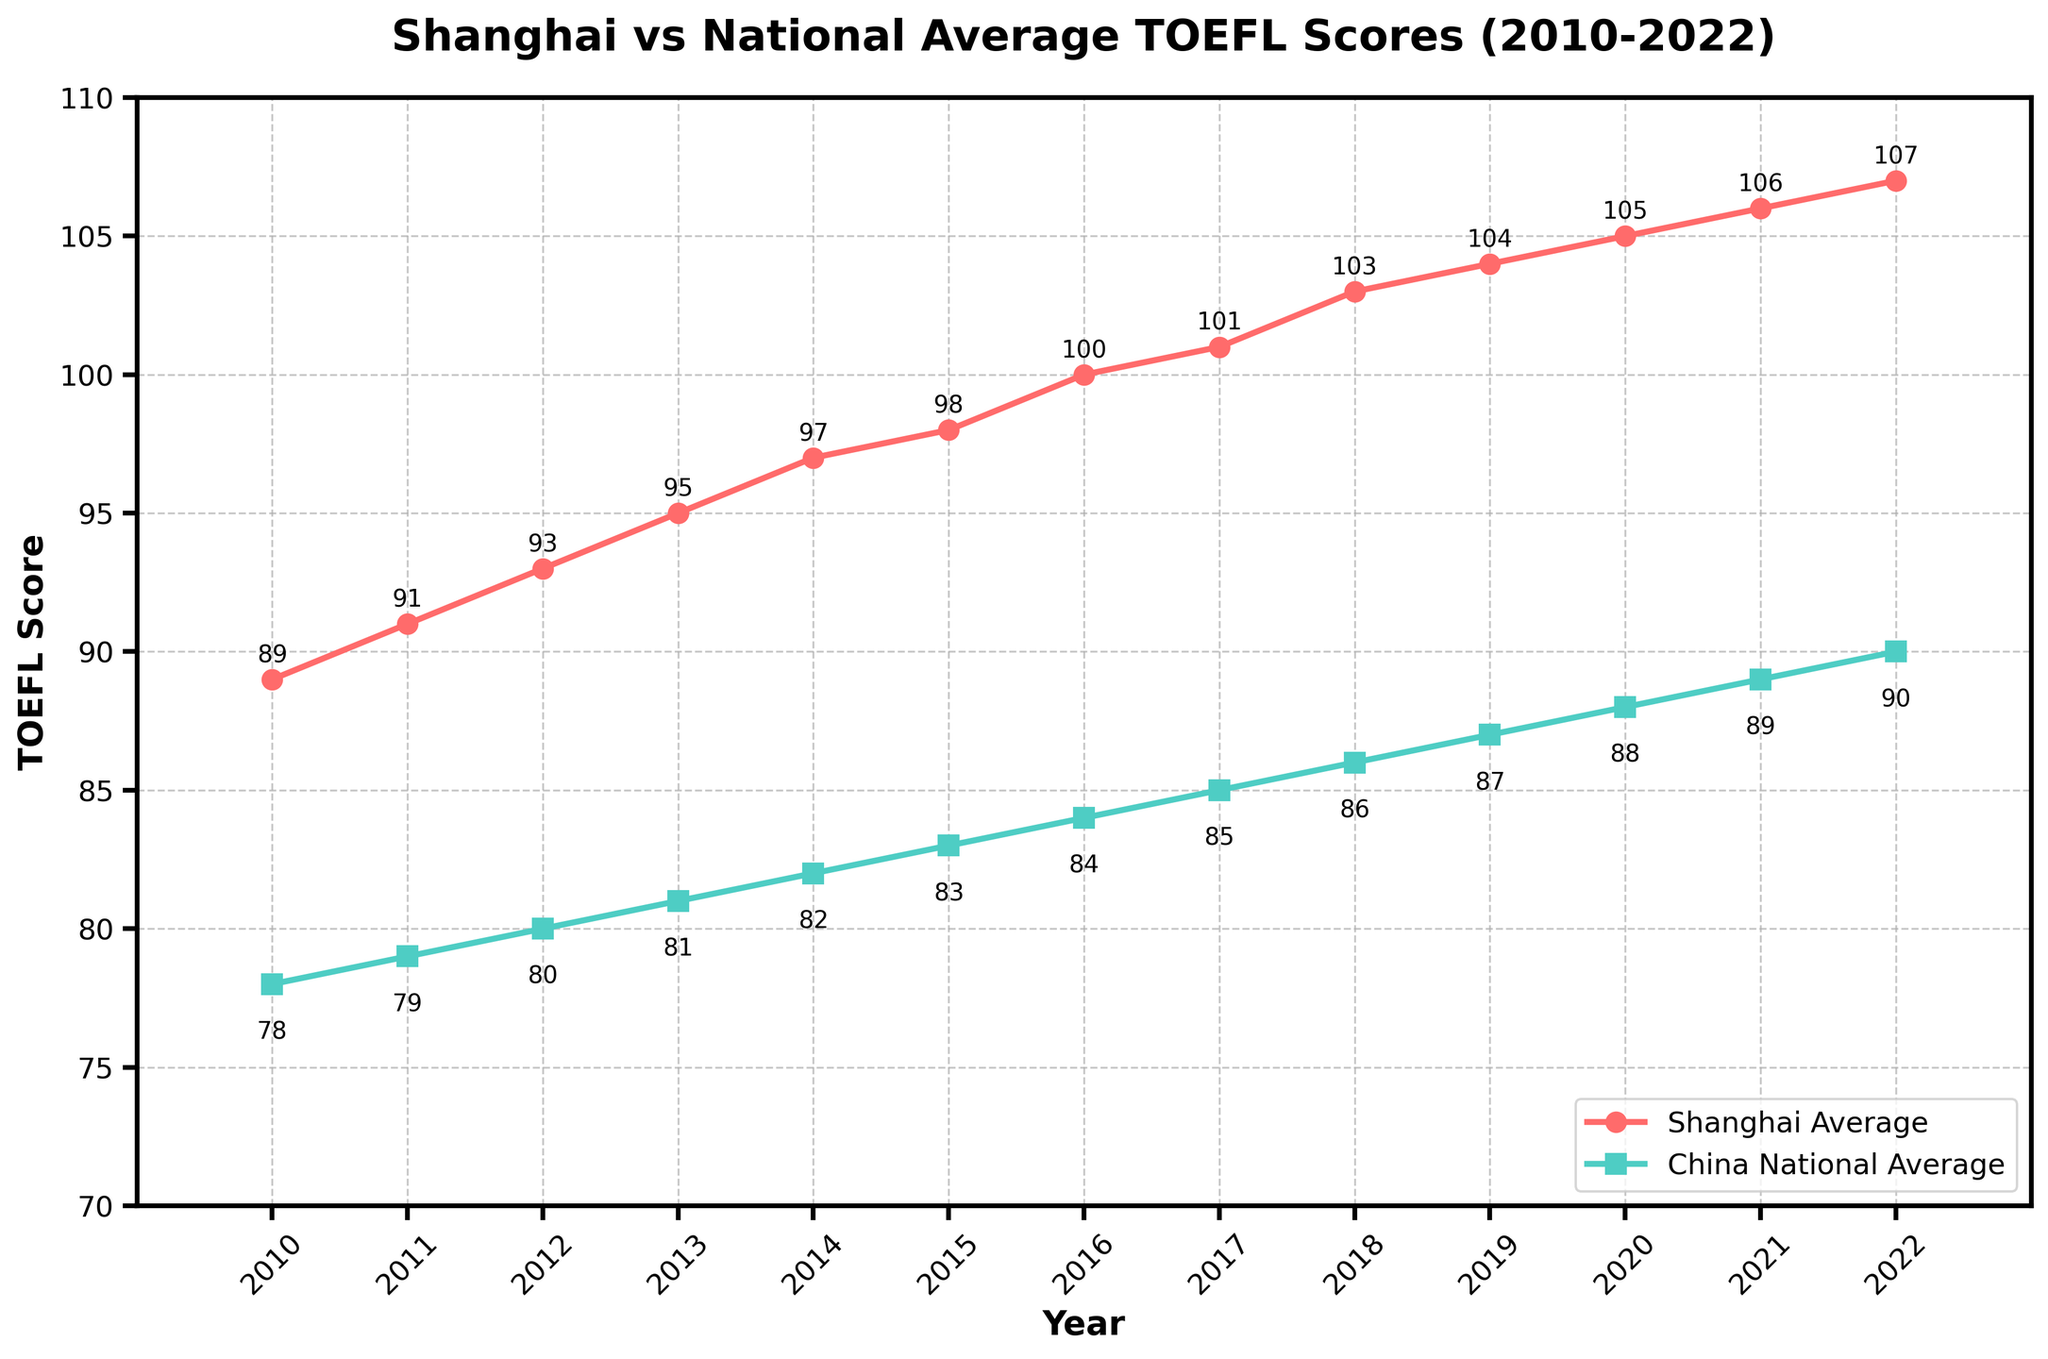What is the TOEFL score difference between Shanghai and the national average in 2015? In 2015, Shanghai's average TOEFL score is 98, and the national average is 83. The difference is 98 - 83 = 15.
Answer: 15 What year did Shanghai first surpass an average TOEFL score of 100? By observing the line chart, Shanghai surpassed an average TOEFL score of 100 in 2016 as the score for that year and subsequent years are 100 or higher.
Answer: 2016 In which year was the gap between Shanghai and the national average the smallest? To determine the smallest gap, we look for the smallest difference between the two lines. In 2010, the difference is 89 - 78 = 11, which is the smallest among all the years.
Answer: 2010 By how much did Shanghai's average TOEFL score increase from 2010 to 2022? Shanghai's average TOEFL score in 2010 was 89, and in 2022 it was 107. The increase is 107 - 89 = 18.
Answer: 18 What is the average national TOEFL score over the 13 years displayed? The national TOEFL scores from 2010 to 2022 are 78, 79, 80, 81, 82, 83, 84, 85, 86, 87, 88, 89, and 90. Summing these scores gives 1092, and the average is 1092 / 13 = 84.
Answer: 84 Which year had the highest TOEFL score in Shanghai? By identifying the peak of the red line, the highest TOEFL score in Shanghai is in 2022, where the score is 107.
Answer: 2022 What is the trend of Shanghai's average TOEFL score from 2010 to 2022? Shanghai's average TOEFL score consistently increases each year from 89 in 2010 to 107 in 2022, indicating a positive upward trend.
Answer: Increasing How much higher was Shanghai’s average score than the national average in 2022? In 2022, Shanghai’s average TOEFL score was 107, whereas the national average was 90. The difference is 107 - 90 = 17.
Answer: 17 By observing the chart, which line represents Shanghai's average TOEFL scores and how can you tell? The line representing Shanghai's average TOEFL scores is red with round markers. It is consistently higher than the national average line and has an increasing trend from 2010 to 2022.
Answer: Red line with round markers Compare the TOEFL score growth rates for Shanghai and the national average between 2010 and 2022. Shanghai's score grew from 89 to 107, an increase of 18 points. The national average grew from 78 to 90, an increase of 12 points. Both scores increased, but Shanghai's growth rate was higher at 18 points compared to the national average’s 12 points.
Answer: Shanghai's growth is higher 